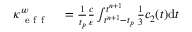Convert formula to latex. <formula><loc_0><loc_0><loc_500><loc_500>\begin{array} { r l } { \kappa _ { e f f } ^ { w } } & = \frac { 1 } { t _ { p } } \frac { c } { \varepsilon } \int _ { t ^ { n + 1 } - t _ { p } } ^ { t ^ { n + 1 } } \frac { 1 } { 3 } c _ { 2 } ( t ) d t } \end{array}</formula> 